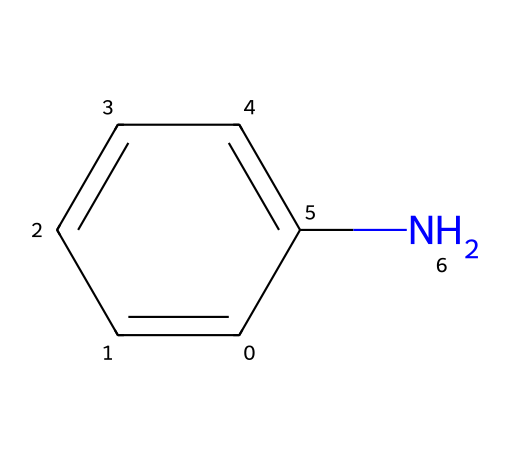What is the molecular formula of aniline? Aniline comprises six carbon atoms, seven hydrogen atoms, and one nitrogen atom, which corresponds to the molecular formula C6H7N.
Answer: C6H7N How many carbon atoms are present in the structure of aniline? Counting the carbon atoms in the SMILES notation reveals that there are six carbon atoms represented.
Answer: 6 What type of functional group is present in aniline? The nitrogen atom in the structure introduces an amine functional group (-NH2), characteristic of aniline.
Answer: amine Is aniline a saturated or unsaturated compound? The presence of a benzene ring indicates that aniline contains alternating double bonds, making it unsaturated.
Answer: unsaturated What is the hybridization of the carbon atoms in aniline? The carbon atoms in the benzene ring are sp2 hybridized due to their involvement in the double bonds and the planarity of the ring structure.
Answer: sp2 What property of aniline contributes to its use in sustainable dyes? The presence of the amine group allows aniline to participate in various chemical reactions, facilitating its use in dye synthesis.
Answer: reactivity Which type of compound does aniline belong to? Aniline is classified as an aromatic compound, given the presence of the aromatic benzene ring in its structure.
Answer: aromatic 